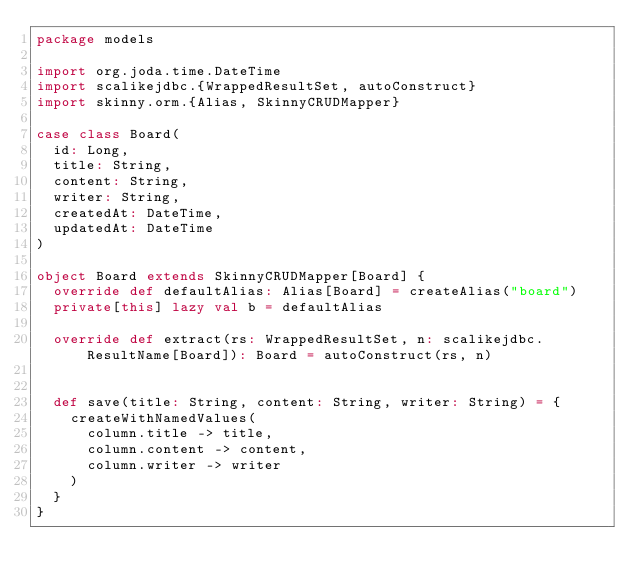Convert code to text. <code><loc_0><loc_0><loc_500><loc_500><_Scala_>package models

import org.joda.time.DateTime
import scalikejdbc.{WrappedResultSet, autoConstruct}
import skinny.orm.{Alias, SkinnyCRUDMapper}

case class Board(
  id: Long,
  title: String,
  content: String,
  writer: String,
  createdAt: DateTime,
  updatedAt: DateTime
)

object Board extends SkinnyCRUDMapper[Board] {
  override def defaultAlias: Alias[Board] = createAlias("board")
  private[this] lazy val b = defaultAlias

  override def extract(rs: WrappedResultSet, n: scalikejdbc.ResultName[Board]): Board = autoConstruct(rs, n)


  def save(title: String, content: String, writer: String) = {
    createWithNamedValues(
      column.title -> title,
      column.content -> content,
      column.writer -> writer
    )
  }
}
</code> 